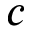<formula> <loc_0><loc_0><loc_500><loc_500>c</formula> 